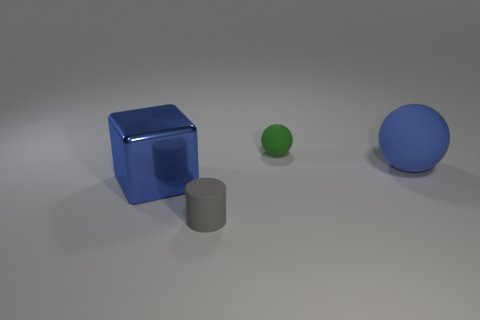Add 3 cylinders. How many objects exist? 7 Subtract all cylinders. How many objects are left? 3 Add 4 blocks. How many blocks exist? 5 Subtract 0 purple cubes. How many objects are left? 4 Subtract all yellow cylinders. Subtract all large blue shiny cubes. How many objects are left? 3 Add 4 tiny gray things. How many tiny gray things are left? 5 